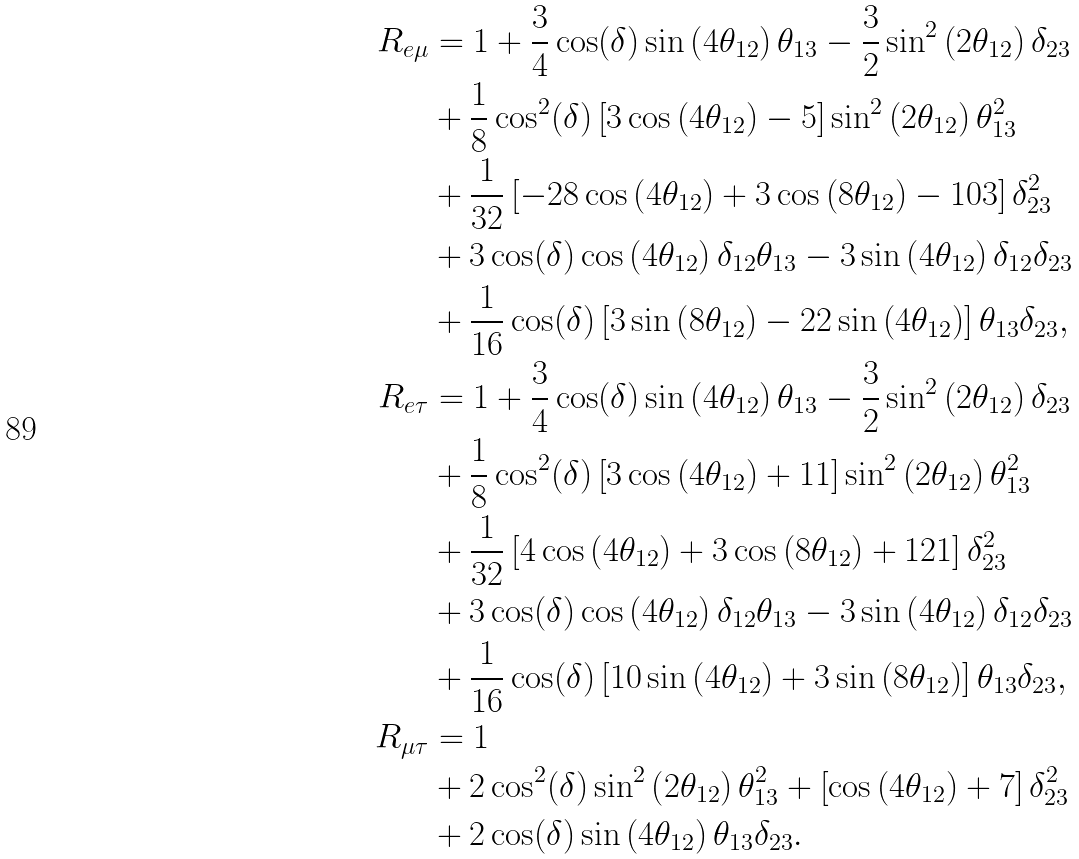<formula> <loc_0><loc_0><loc_500><loc_500>R _ { e \mu } & = 1 + \frac { 3 } { 4 } \cos ( \delta ) \sin \left ( 4 \theta _ { 1 2 } \right ) \theta _ { 1 3 } - \frac { 3 } { 2 } \sin ^ { 2 } \left ( 2 \theta _ { 1 2 } \right ) \delta _ { 2 3 } \\ & + \frac { 1 } { 8 } \cos ^ { 2 } ( \delta ) \left [ 3 \cos \left ( 4 \theta _ { 1 2 } \right ) - 5 \right ] \sin ^ { 2 } \left ( 2 \theta _ { 1 2 } \right ) \theta _ { 1 3 } ^ { 2 } \\ & + \frac { 1 } { 3 2 } \left [ - 2 8 \cos \left ( 4 \theta _ { 1 2 } \right ) + 3 \cos \left ( 8 \theta _ { 1 2 } \right ) - 1 0 3 \right ] \delta _ { 2 3 } ^ { 2 } \\ & + 3 \cos ( \delta ) \cos \left ( 4 \theta _ { 1 2 } \right ) \delta _ { 1 2 } \theta _ { 1 3 } - 3 \sin \left ( 4 \theta _ { 1 2 } \right ) \delta _ { 1 2 } \delta _ { 2 3 } \\ & + \frac { 1 } { 1 6 } \cos ( \delta ) \left [ 3 \sin \left ( 8 \theta _ { 1 2 } \right ) - 2 2 \sin \left ( 4 \theta _ { 1 2 } \right ) \right ] \theta _ { 1 3 } \delta _ { 2 3 } , \\ R _ { e \tau } & = 1 + \frac { 3 } { 4 } \cos ( \delta ) \sin \left ( 4 \theta _ { 1 2 } \right ) \theta _ { 1 3 } - \frac { 3 } { 2 } \sin ^ { 2 } \left ( 2 \theta _ { 1 2 } \right ) \delta _ { 2 3 } \\ & + \frac { 1 } { 8 } \cos ^ { 2 } ( \delta ) \left [ 3 \cos \left ( 4 \theta _ { 1 2 } \right ) + 1 1 \right ] \sin ^ { 2 } \left ( 2 \theta _ { 1 2 } \right ) \theta _ { 1 3 } ^ { 2 } \\ & + \frac { 1 } { 3 2 } \left [ 4 \cos \left ( 4 \theta _ { 1 2 } \right ) + 3 \cos \left ( 8 \theta _ { 1 2 } \right ) + 1 2 1 \right ] \delta _ { 2 3 } ^ { 2 } \\ & + 3 \cos ( \delta ) \cos \left ( 4 \theta _ { 1 2 } \right ) \delta _ { 1 2 } \theta _ { 1 3 } - 3 \sin \left ( 4 \theta _ { 1 2 } \right ) \delta _ { 1 2 } \delta _ { 2 3 } \\ & + \frac { 1 } { 1 6 } \cos ( \delta ) \left [ 1 0 \sin \left ( 4 \theta _ { 1 2 } \right ) + 3 \sin \left ( 8 \theta _ { 1 2 } \right ) \right ] \theta _ { 1 3 } \delta _ { 2 3 } , \\ R _ { \mu \tau } & = 1 \\ & + 2 \cos ^ { 2 } ( \delta ) \sin ^ { 2 } \left ( 2 \theta _ { 1 2 } \right ) \theta _ { 1 3 } ^ { 2 } + \left [ \cos \left ( 4 \theta _ { 1 2 } \right ) + 7 \right ] \delta _ { 2 3 } ^ { 2 } \\ & + 2 \cos ( \delta ) \sin \left ( 4 \theta _ { 1 2 } \right ) \theta _ { 1 3 } \delta _ { 2 3 } .</formula> 